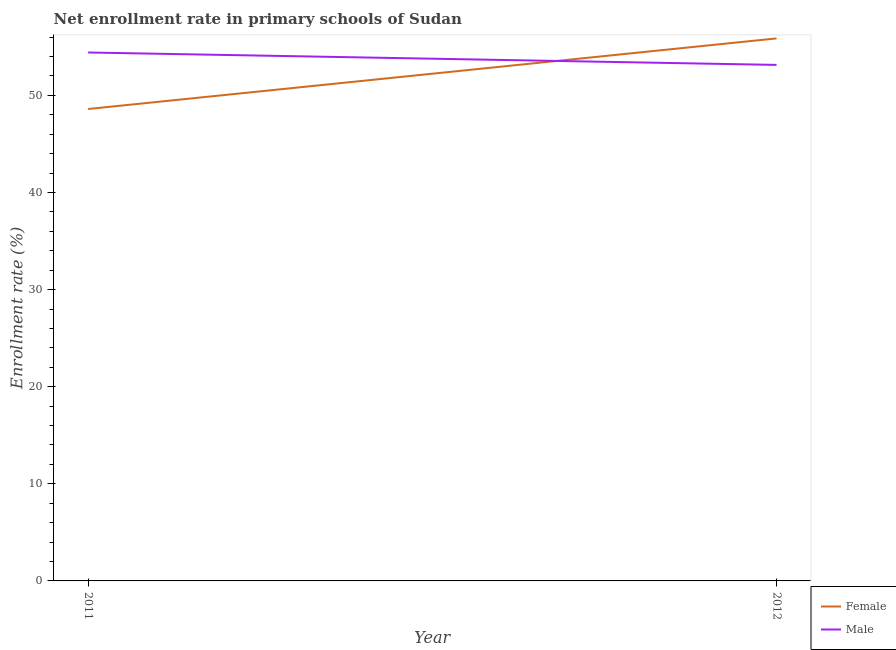Is the number of lines equal to the number of legend labels?
Keep it short and to the point. Yes. What is the enrollment rate of female students in 2012?
Give a very brief answer. 55.87. Across all years, what is the maximum enrollment rate of female students?
Offer a terse response. 55.87. Across all years, what is the minimum enrollment rate of female students?
Provide a short and direct response. 48.6. In which year was the enrollment rate of female students maximum?
Ensure brevity in your answer.  2012. In which year was the enrollment rate of male students minimum?
Provide a short and direct response. 2012. What is the total enrollment rate of male students in the graph?
Provide a short and direct response. 107.56. What is the difference between the enrollment rate of male students in 2011 and that in 2012?
Provide a short and direct response. 1.28. What is the difference between the enrollment rate of male students in 2011 and the enrollment rate of female students in 2012?
Offer a very short reply. -1.45. What is the average enrollment rate of male students per year?
Offer a terse response. 53.78. In the year 2011, what is the difference between the enrollment rate of male students and enrollment rate of female students?
Ensure brevity in your answer.  5.82. What is the ratio of the enrollment rate of male students in 2011 to that in 2012?
Make the answer very short. 1.02. In how many years, is the enrollment rate of male students greater than the average enrollment rate of male students taken over all years?
Make the answer very short. 1. How many years are there in the graph?
Ensure brevity in your answer.  2. What is the difference between two consecutive major ticks on the Y-axis?
Your response must be concise. 10. Are the values on the major ticks of Y-axis written in scientific E-notation?
Make the answer very short. No. Does the graph contain any zero values?
Give a very brief answer. No. Does the graph contain grids?
Give a very brief answer. No. What is the title of the graph?
Make the answer very short. Net enrollment rate in primary schools of Sudan. What is the label or title of the Y-axis?
Your answer should be very brief. Enrollment rate (%). What is the Enrollment rate (%) of Female in 2011?
Provide a succinct answer. 48.6. What is the Enrollment rate (%) of Male in 2011?
Your answer should be very brief. 54.42. What is the Enrollment rate (%) in Female in 2012?
Make the answer very short. 55.87. What is the Enrollment rate (%) in Male in 2012?
Give a very brief answer. 53.14. Across all years, what is the maximum Enrollment rate (%) of Female?
Provide a succinct answer. 55.87. Across all years, what is the maximum Enrollment rate (%) in Male?
Make the answer very short. 54.42. Across all years, what is the minimum Enrollment rate (%) in Female?
Provide a succinct answer. 48.6. Across all years, what is the minimum Enrollment rate (%) in Male?
Provide a succinct answer. 53.14. What is the total Enrollment rate (%) of Female in the graph?
Your answer should be compact. 104.47. What is the total Enrollment rate (%) of Male in the graph?
Your response must be concise. 107.56. What is the difference between the Enrollment rate (%) of Female in 2011 and that in 2012?
Your response must be concise. -7.27. What is the difference between the Enrollment rate (%) of Male in 2011 and that in 2012?
Give a very brief answer. 1.28. What is the difference between the Enrollment rate (%) in Female in 2011 and the Enrollment rate (%) in Male in 2012?
Your answer should be very brief. -4.54. What is the average Enrollment rate (%) in Female per year?
Provide a succinct answer. 52.23. What is the average Enrollment rate (%) in Male per year?
Offer a very short reply. 53.78. In the year 2011, what is the difference between the Enrollment rate (%) of Female and Enrollment rate (%) of Male?
Keep it short and to the point. -5.82. In the year 2012, what is the difference between the Enrollment rate (%) in Female and Enrollment rate (%) in Male?
Offer a terse response. 2.73. What is the ratio of the Enrollment rate (%) of Female in 2011 to that in 2012?
Keep it short and to the point. 0.87. What is the ratio of the Enrollment rate (%) of Male in 2011 to that in 2012?
Your answer should be very brief. 1.02. What is the difference between the highest and the second highest Enrollment rate (%) in Female?
Your response must be concise. 7.27. What is the difference between the highest and the second highest Enrollment rate (%) of Male?
Offer a terse response. 1.28. What is the difference between the highest and the lowest Enrollment rate (%) in Female?
Give a very brief answer. 7.27. What is the difference between the highest and the lowest Enrollment rate (%) of Male?
Provide a short and direct response. 1.28. 